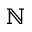<formula> <loc_0><loc_0><loc_500><loc_500>\mathbb { N }</formula> 